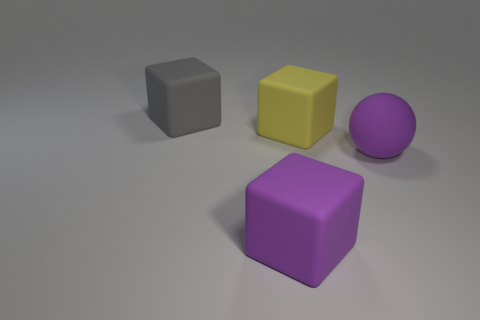The ball that is the same size as the yellow matte thing is what color?
Your answer should be compact. Purple. There is a large yellow rubber object; is it the same shape as the purple object that is right of the yellow matte cube?
Ensure brevity in your answer.  No. What shape is the thing that is the same color as the big matte ball?
Give a very brief answer. Cube. There is a big yellow rubber object that is right of the purple thing that is to the left of the large yellow matte cube; how many purple matte things are behind it?
Offer a very short reply. 0. There is a object that is in front of the purple thing right of the big yellow cube; how big is it?
Provide a short and direct response. Large. What is the size of the gray thing that is made of the same material as the yellow block?
Make the answer very short. Large. There is a object that is behind the big purple matte ball and in front of the big gray rubber block; what shape is it?
Keep it short and to the point. Cube. Is the number of yellow things on the left side of the purple matte cube the same as the number of gray things?
Keep it short and to the point. No. How many things are either big spheres or matte objects that are on the left side of the yellow rubber block?
Ensure brevity in your answer.  3. Are there any big yellow things that have the same shape as the gray thing?
Ensure brevity in your answer.  Yes. 